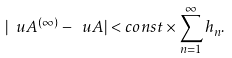Convert formula to latex. <formula><loc_0><loc_0><loc_500><loc_500>| { \ u A } ^ { ( \infty ) } - { \ u A } | < c o n s t \times \sum _ { n = 1 } ^ { \infty } h _ { n } .</formula> 